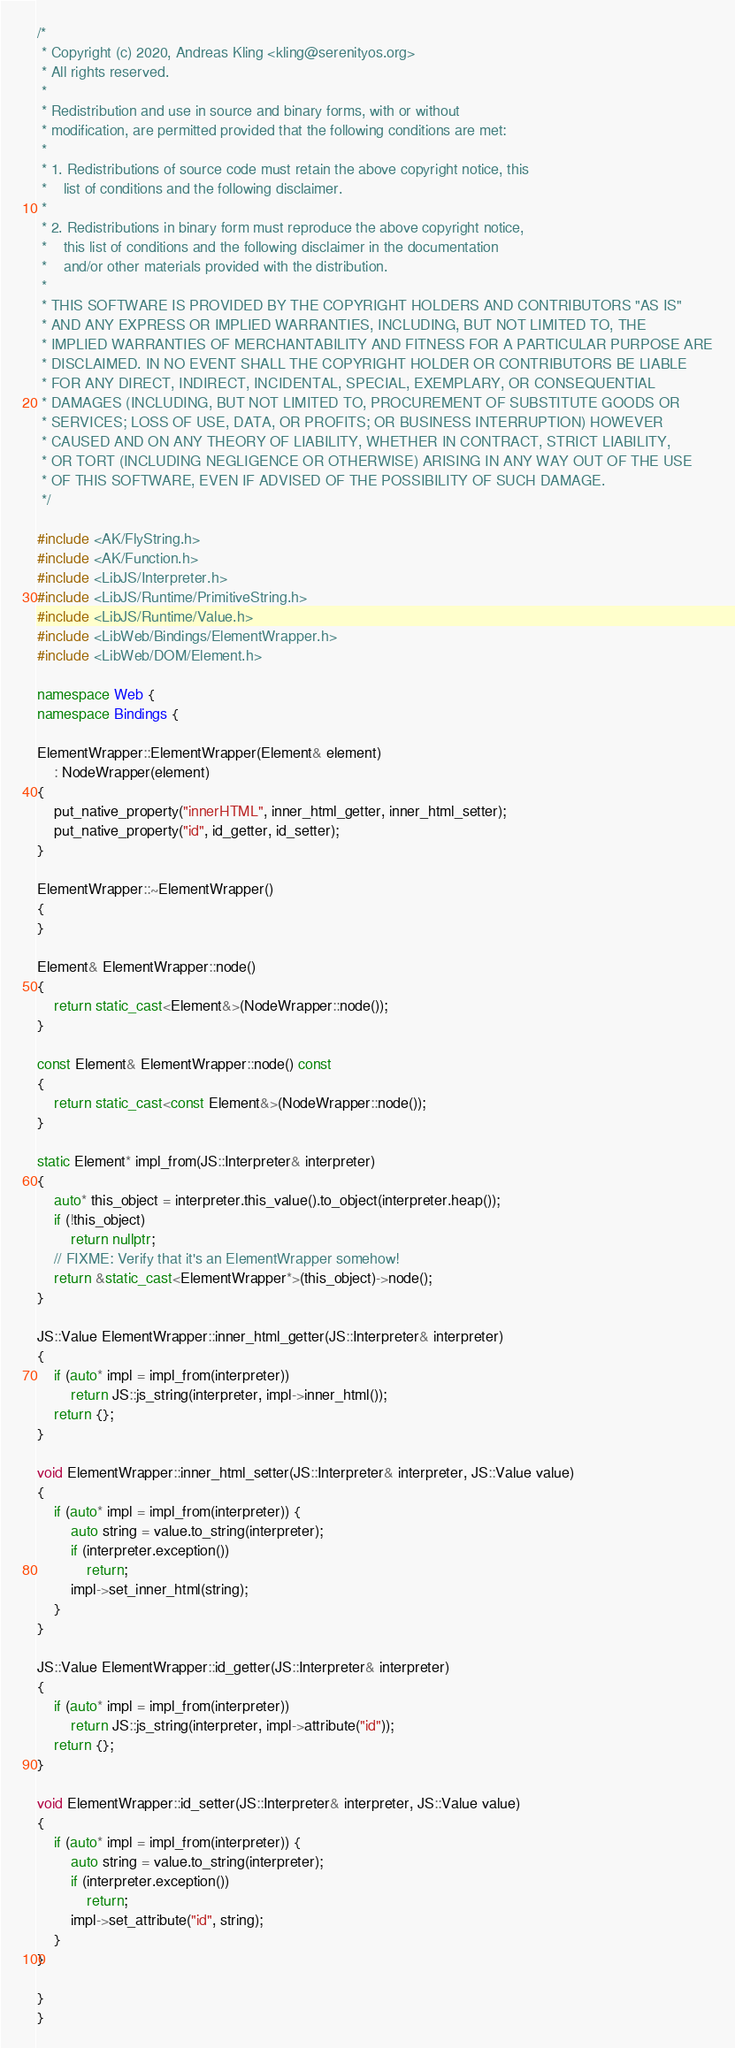Convert code to text. <code><loc_0><loc_0><loc_500><loc_500><_C++_>/*
 * Copyright (c) 2020, Andreas Kling <kling@serenityos.org>
 * All rights reserved.
 *
 * Redistribution and use in source and binary forms, with or without
 * modification, are permitted provided that the following conditions are met:
 *
 * 1. Redistributions of source code must retain the above copyright notice, this
 *    list of conditions and the following disclaimer.
 *
 * 2. Redistributions in binary form must reproduce the above copyright notice,
 *    this list of conditions and the following disclaimer in the documentation
 *    and/or other materials provided with the distribution.
 *
 * THIS SOFTWARE IS PROVIDED BY THE COPYRIGHT HOLDERS AND CONTRIBUTORS "AS IS"
 * AND ANY EXPRESS OR IMPLIED WARRANTIES, INCLUDING, BUT NOT LIMITED TO, THE
 * IMPLIED WARRANTIES OF MERCHANTABILITY AND FITNESS FOR A PARTICULAR PURPOSE ARE
 * DISCLAIMED. IN NO EVENT SHALL THE COPYRIGHT HOLDER OR CONTRIBUTORS BE LIABLE
 * FOR ANY DIRECT, INDIRECT, INCIDENTAL, SPECIAL, EXEMPLARY, OR CONSEQUENTIAL
 * DAMAGES (INCLUDING, BUT NOT LIMITED TO, PROCUREMENT OF SUBSTITUTE GOODS OR
 * SERVICES; LOSS OF USE, DATA, OR PROFITS; OR BUSINESS INTERRUPTION) HOWEVER
 * CAUSED AND ON ANY THEORY OF LIABILITY, WHETHER IN CONTRACT, STRICT LIABILITY,
 * OR TORT (INCLUDING NEGLIGENCE OR OTHERWISE) ARISING IN ANY WAY OUT OF THE USE
 * OF THIS SOFTWARE, EVEN IF ADVISED OF THE POSSIBILITY OF SUCH DAMAGE.
 */

#include <AK/FlyString.h>
#include <AK/Function.h>
#include <LibJS/Interpreter.h>
#include <LibJS/Runtime/PrimitiveString.h>
#include <LibJS/Runtime/Value.h>
#include <LibWeb/Bindings/ElementWrapper.h>
#include <LibWeb/DOM/Element.h>

namespace Web {
namespace Bindings {

ElementWrapper::ElementWrapper(Element& element)
    : NodeWrapper(element)
{
    put_native_property("innerHTML", inner_html_getter, inner_html_setter);
    put_native_property("id", id_getter, id_setter);
}

ElementWrapper::~ElementWrapper()
{
}

Element& ElementWrapper::node()
{
    return static_cast<Element&>(NodeWrapper::node());
}

const Element& ElementWrapper::node() const
{
    return static_cast<const Element&>(NodeWrapper::node());
}

static Element* impl_from(JS::Interpreter& interpreter)
{
    auto* this_object = interpreter.this_value().to_object(interpreter.heap());
    if (!this_object)
        return nullptr;
    // FIXME: Verify that it's an ElementWrapper somehow!
    return &static_cast<ElementWrapper*>(this_object)->node();
}

JS::Value ElementWrapper::inner_html_getter(JS::Interpreter& interpreter)
{
    if (auto* impl = impl_from(interpreter))
        return JS::js_string(interpreter, impl->inner_html());
    return {};
}

void ElementWrapper::inner_html_setter(JS::Interpreter& interpreter, JS::Value value)
{
    if (auto* impl = impl_from(interpreter)) {
        auto string = value.to_string(interpreter);
        if (interpreter.exception())
            return;
        impl->set_inner_html(string);
    }
}

JS::Value ElementWrapper::id_getter(JS::Interpreter& interpreter)
{
    if (auto* impl = impl_from(interpreter))
        return JS::js_string(interpreter, impl->attribute("id"));
    return {};
}

void ElementWrapper::id_setter(JS::Interpreter& interpreter, JS::Value value)
{
    if (auto* impl = impl_from(interpreter)) {
        auto string = value.to_string(interpreter);
        if (interpreter.exception())
            return;
        impl->set_attribute("id", string);
    }
}

}
}
</code> 